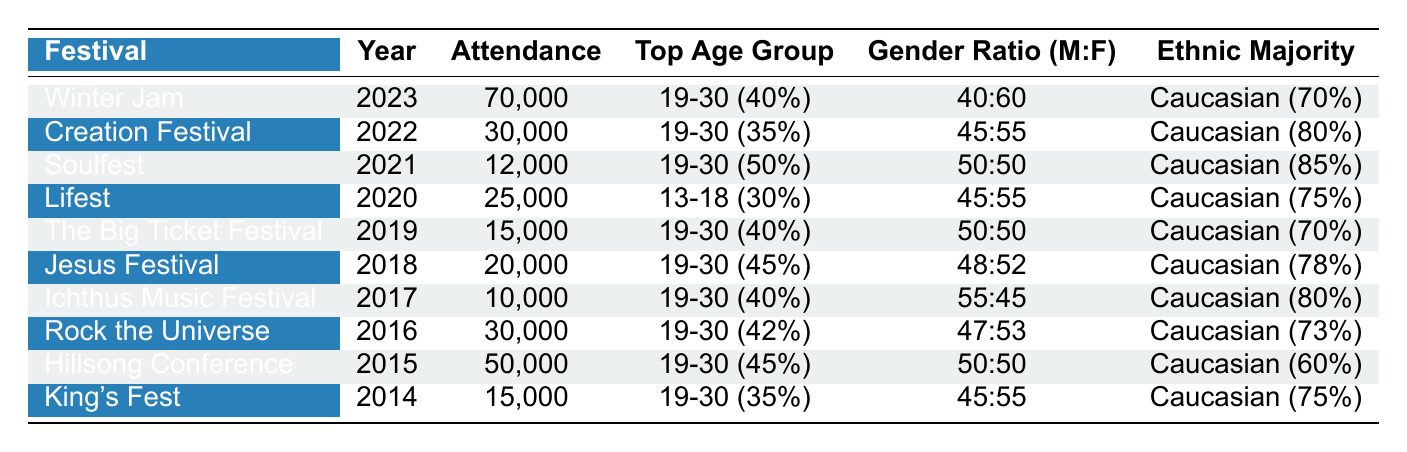What festival had the highest attendance? Looking at the 'Attendance' column, Winter Jam in 2023 had the highest attendance with 70,000 people.
Answer: Winter Jam What year did the Hillsong Conference take place? The Hillsong Conference was held in the year 2015 as indicated in the 'Year' column.
Answer: 2015 Which festival had an equal gender ratio? Soulfest in 2021 had an equal gender ratio of 50% male and 50% female, as mentioned in the 'Gender Ratio (M:F)' column.
Answer: Soulfest What is the ethnic majority at Creation Festival? The ethnic majority at Creation Festival in 2022 is Caucasian, which is noted in the 'Ethnic Majority' column (80%).
Answer: Caucasian Which festival has the largest percentage of attendees aged 19-30? Soulfest in 2021 had the largest percentage of attendees aged 19-30 at 50%. Looking at the 'Top Age Group' column, this is the highest percentage provided for that demographic.
Answer: Soulfest What is the average attendance of the festivals listed? The total attendance is 70,000 + 30,000 + 12,000 + 25,000 + 15,000 + 20,000 + 10,000 + 30,000 + 50,000 + 15,000 =  337,000. There are 10 festivals, so the average attendance is 337,000 / 10 = 33,700.
Answer: 33,700 Was the majority of attendees at King's Fest in the age group 31-50? No, the majority attended the 19-30 age group at 35%, as indicated in the 'Top Age Group' column.
Answer: No What are the top two festivals with the highest attendance in consecutive years? The top two festivals with the highest attendance were Winter Jam (2023, 70,000) followed by Creation Festival (2022, 30,000). These values are noted in the 'Attendance' column and correspond to their respective years.
Answer: Winter Jam and Creation Festival How many festivals had more than 20,000 attendees? The festivals above 20,000 attendees are Winter Jam (70,000), Creation Festival (30,000), Lifest (25,000), The Big Ticket Festival (15,000), and Hillsong Conference (50,000). That gives a total of 5 festivals listed above 20,000.
Answer: 4 What was the gender ratio at the Jesus Festival? The gender ratio at the Jesus Festival was 48% male to 52% female, as shown in the 'Gender Ratio (M:F)' column.
Answer: 48:52 